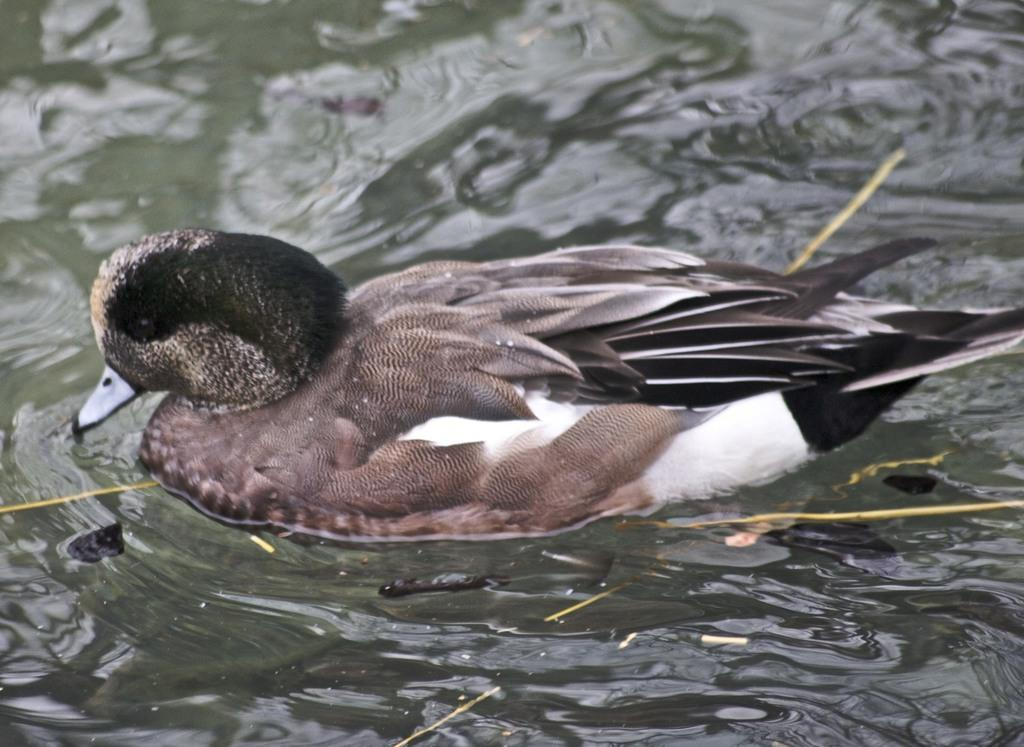Where was the picture taken? The picture was taken outside. What type of animal can be seen in the image? There is a bird, possibly a duck, in the image. What is the bird doing in the image? The bird is swimming in a water body. Are there any other objects or animals in the water body? Yes, there are other objects in the water body. What type of appliance can be seen floating in the water body? There is no appliance present in the image; it features a bird swimming in a water body with other objects. 